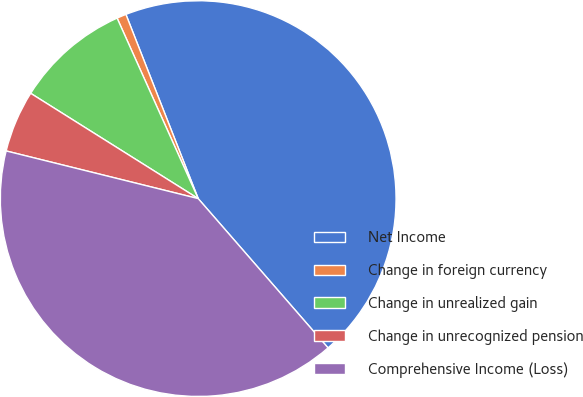<chart> <loc_0><loc_0><loc_500><loc_500><pie_chart><fcel>Net Income<fcel>Change in foreign currency<fcel>Change in unrealized gain<fcel>Change in unrecognized pension<fcel>Comprehensive Income (Loss)<nl><fcel>44.56%<fcel>0.77%<fcel>9.35%<fcel>5.06%<fcel>40.27%<nl></chart> 